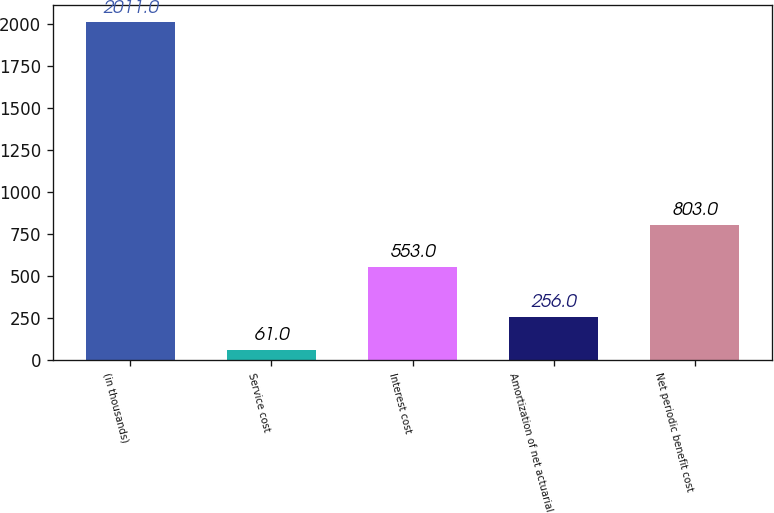Convert chart. <chart><loc_0><loc_0><loc_500><loc_500><bar_chart><fcel>(in thousands)<fcel>Service cost<fcel>Interest cost<fcel>Amortization of net actuarial<fcel>Net periodic benefit cost<nl><fcel>2011<fcel>61<fcel>553<fcel>256<fcel>803<nl></chart> 